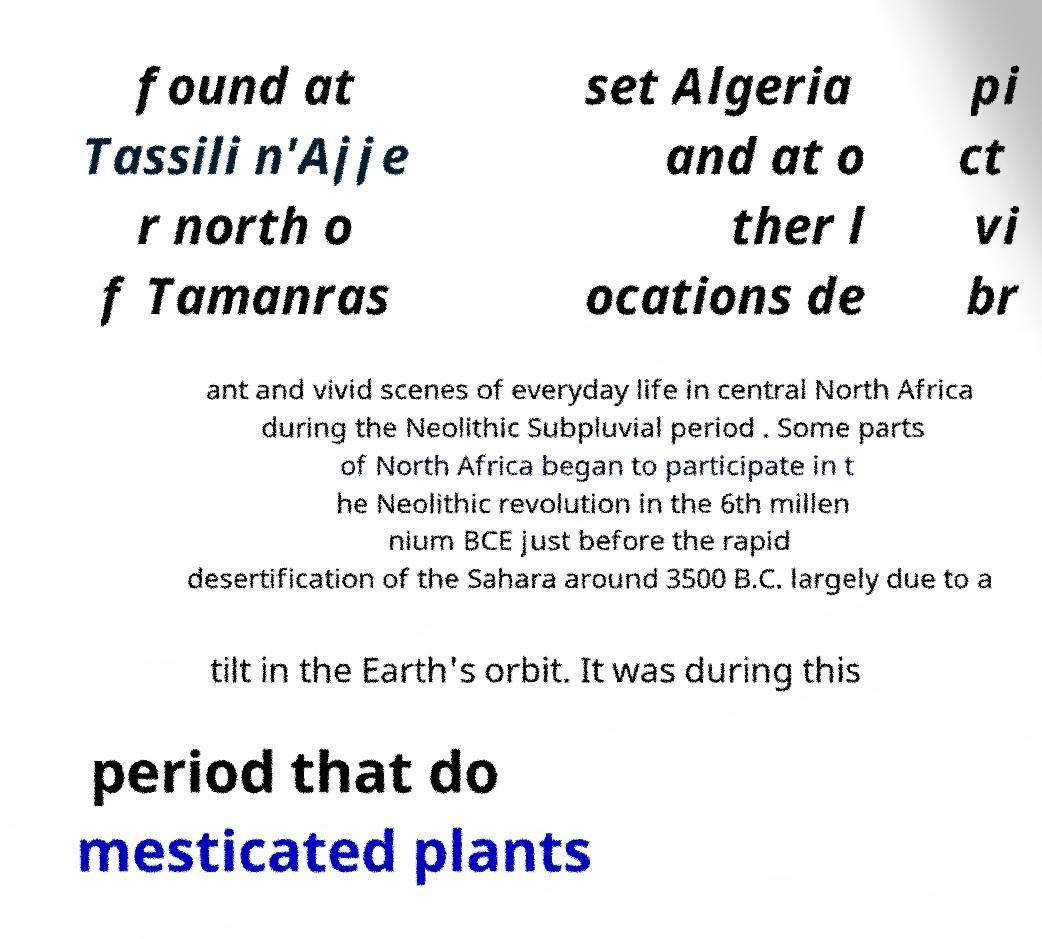I need the written content from this picture converted into text. Can you do that? found at Tassili n'Ajje r north o f Tamanras set Algeria and at o ther l ocations de pi ct vi br ant and vivid scenes of everyday life in central North Africa during the Neolithic Subpluvial period . Some parts of North Africa began to participate in t he Neolithic revolution in the 6th millen nium BCE just before the rapid desertification of the Sahara around 3500 B.C. largely due to a tilt in the Earth's orbit. It was during this period that do mesticated plants 